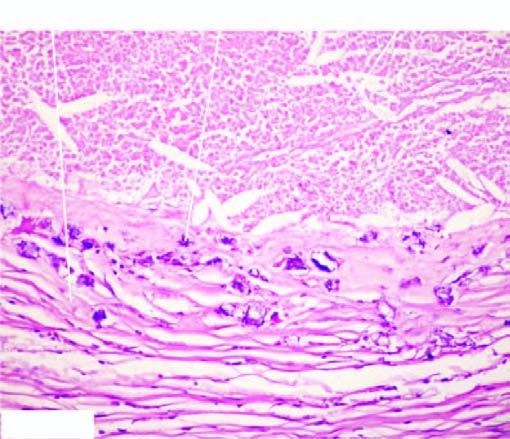re the deposits basophilic granular while the periphery shows healed granulomas?
Answer the question using a single word or phrase. Yes 